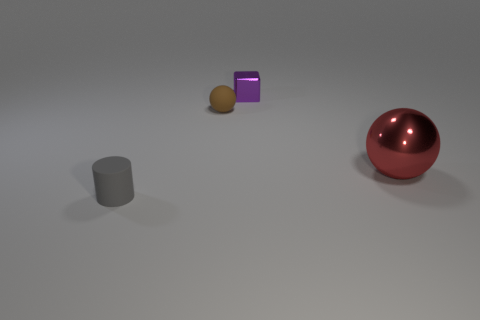Can you tell me the materials of the objects present? Certainly! The large sphere appears to be made of a polished metal due to its reflective surface and luster. The cube looks like it could be made of a matte plastic or non-reflective metal, and the cylinder and small sphere seem to have matte finishes as well, which could indicate a rubbery or plastic material. Are these objects typically found together? Not commonly. These objects appear to be a collection of geometric shapes that are often used in 3D modeling and rendering tests, rather than items that serve a shared functional purpose. 